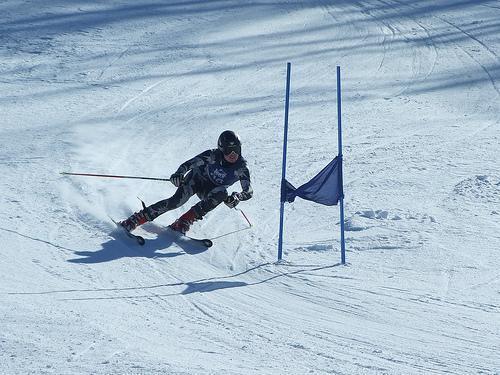How many skiers are there?
Give a very brief answer. 1. 